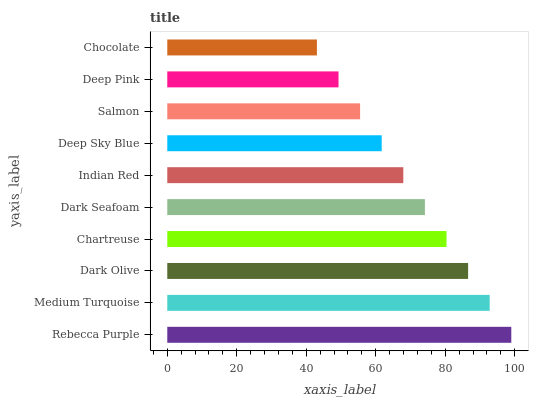Is Chocolate the minimum?
Answer yes or no. Yes. Is Rebecca Purple the maximum?
Answer yes or no. Yes. Is Medium Turquoise the minimum?
Answer yes or no. No. Is Medium Turquoise the maximum?
Answer yes or no. No. Is Rebecca Purple greater than Medium Turquoise?
Answer yes or no. Yes. Is Medium Turquoise less than Rebecca Purple?
Answer yes or no. Yes. Is Medium Turquoise greater than Rebecca Purple?
Answer yes or no. No. Is Rebecca Purple less than Medium Turquoise?
Answer yes or no. No. Is Dark Seafoam the high median?
Answer yes or no. Yes. Is Indian Red the low median?
Answer yes or no. Yes. Is Salmon the high median?
Answer yes or no. No. Is Dark Olive the low median?
Answer yes or no. No. 